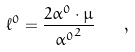<formula> <loc_0><loc_0><loc_500><loc_500>\ell ^ { 0 } = \frac { 2 \alpha ^ { 0 } \cdot \mu } { { \alpha ^ { 0 } } ^ { 2 } } \quad ,</formula> 